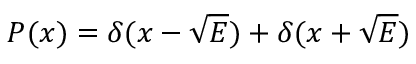<formula> <loc_0><loc_0><loc_500><loc_500>P ( x ) = \delta ( x - \sqrt { E } ) + \delta ( x + \sqrt { E } )</formula> 